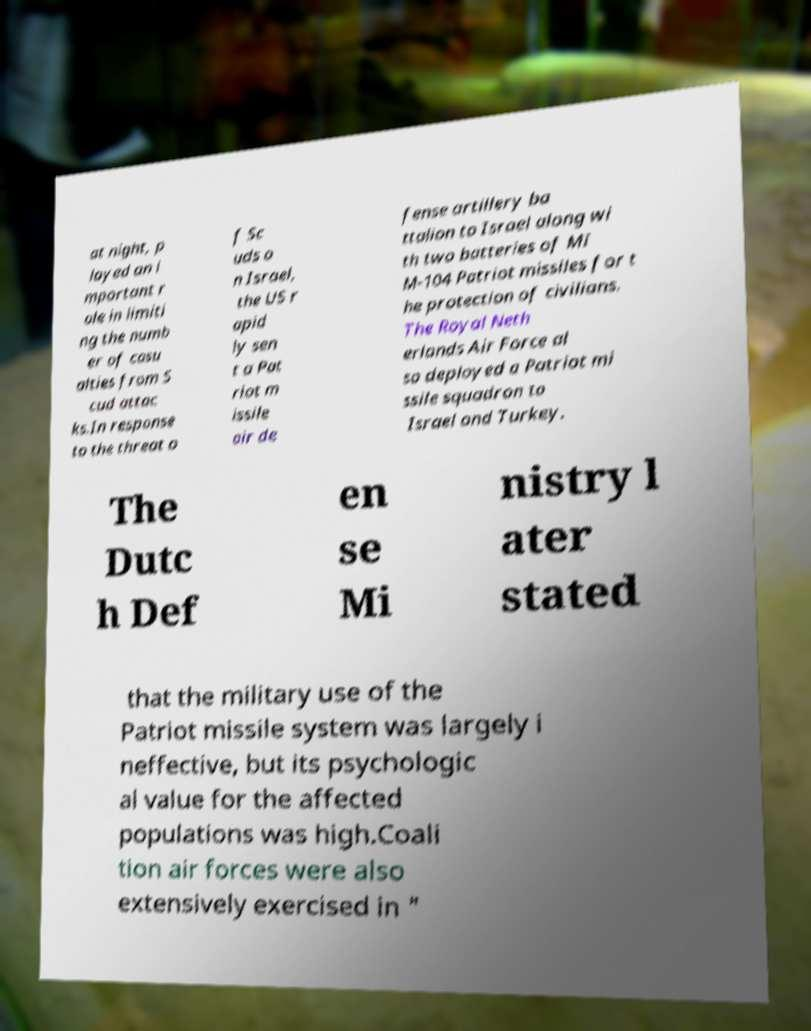Could you extract and type out the text from this image? at night, p layed an i mportant r ole in limiti ng the numb er of casu alties from S cud attac ks.In response to the threat o f Sc uds o n Israel, the US r apid ly sen t a Pat riot m issile air de fense artillery ba ttalion to Israel along wi th two batteries of MI M-104 Patriot missiles for t he protection of civilians. The Royal Neth erlands Air Force al so deployed a Patriot mi ssile squadron to Israel and Turkey. The Dutc h Def en se Mi nistry l ater stated that the military use of the Patriot missile system was largely i neffective, but its psychologic al value for the affected populations was high.Coali tion air forces were also extensively exercised in " 